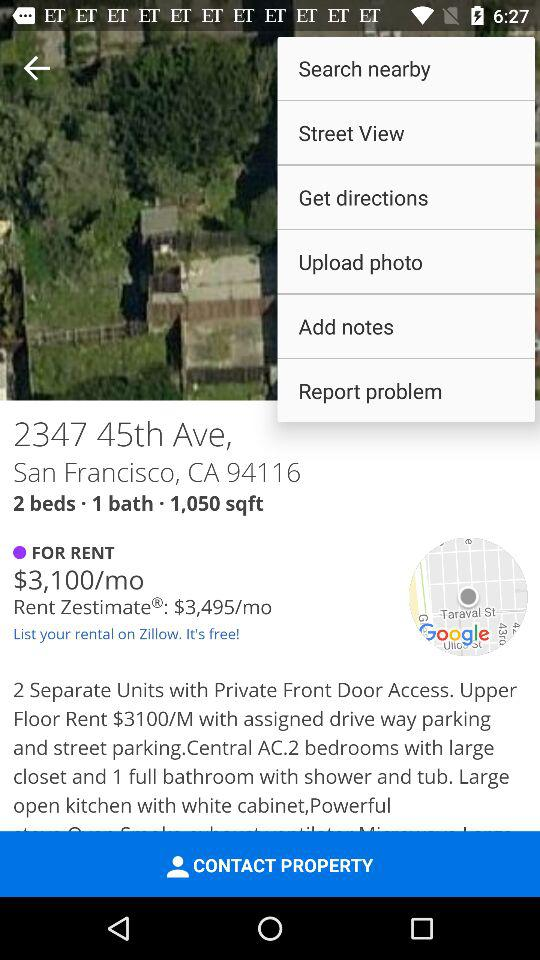How much is the "Rent Zestimate"? The "Rent Zestimate" is $3,495/month. 